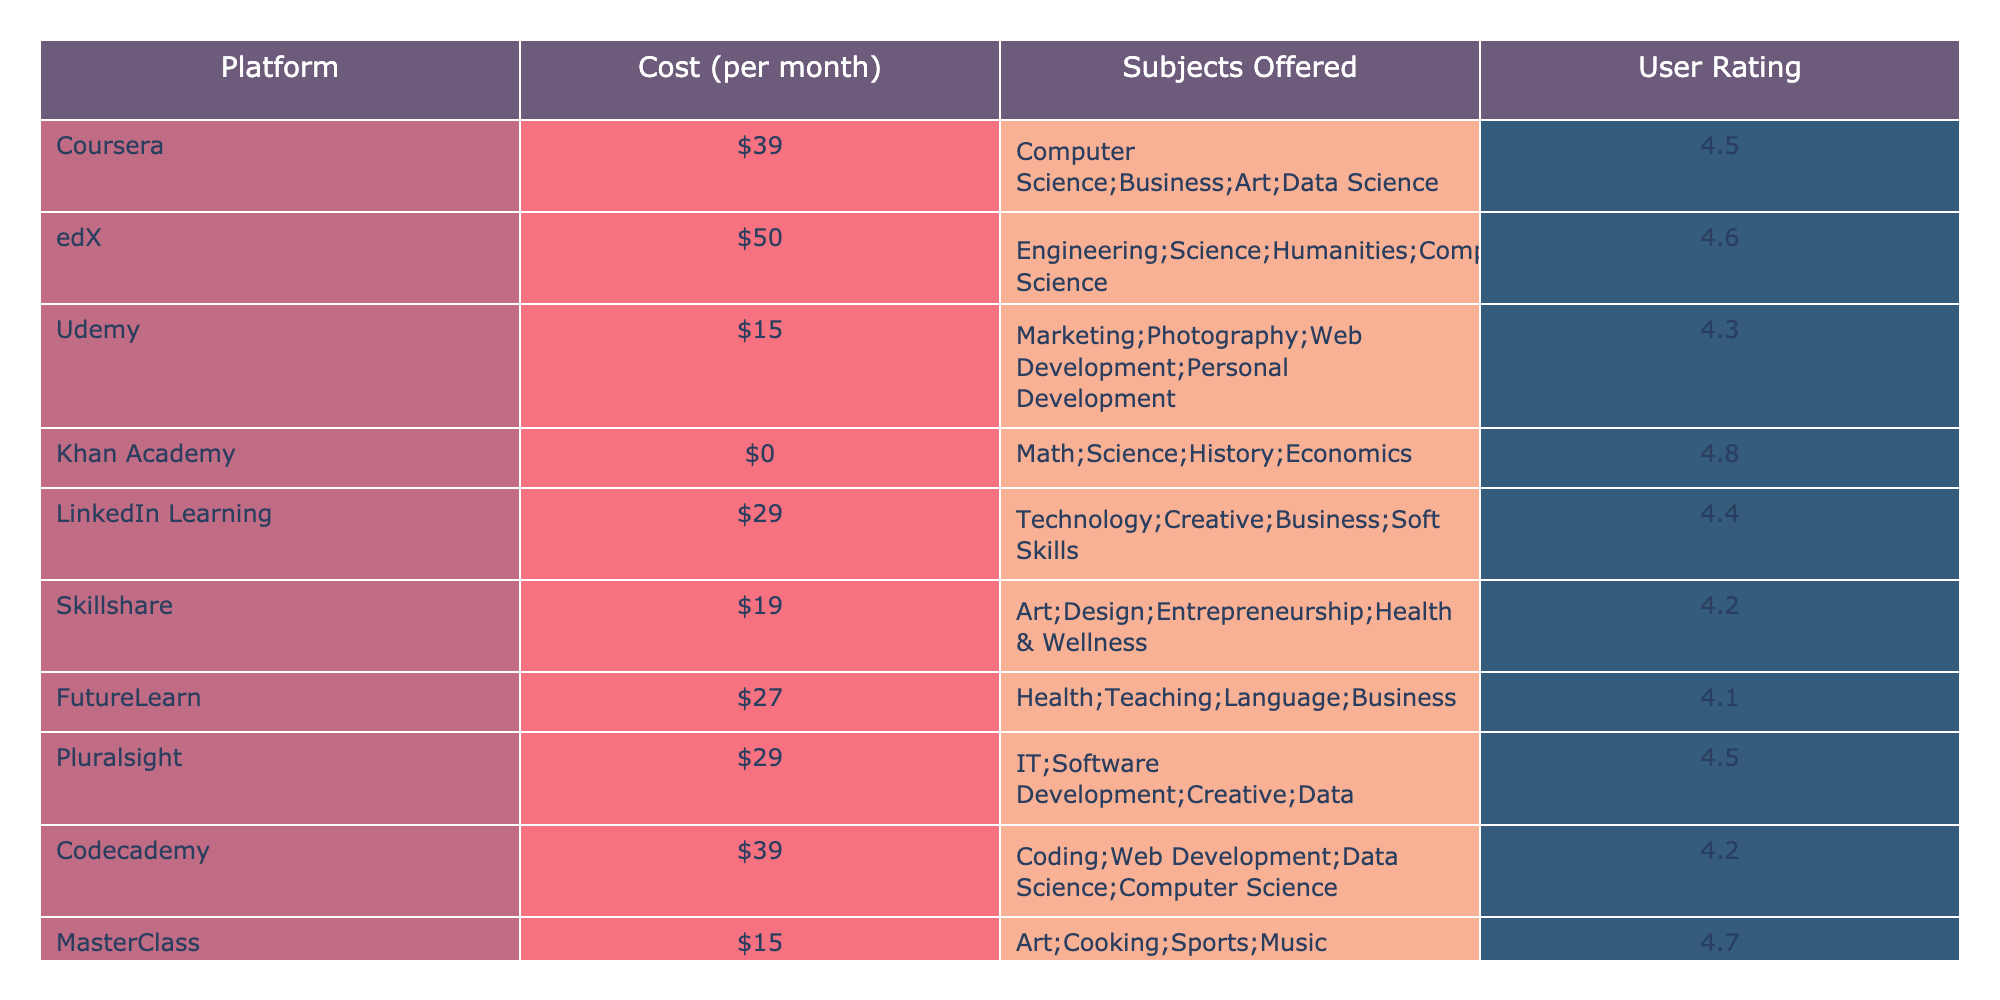What is the cost of Udemy per month? According to the table, Udemy has a cost of $15 per month listed in the Cost column.
Answer: $15 Which platform has the highest user rating? By checking the User Rating column, Khan Academy has the highest rating of 4.8.
Answer: Khan Academy How many subjects does Coursera offer? The Subjects Offered column shows that Coursera offers four subjects: Computer Science, Business, Art, and Data Science.
Answer: 4 Is it true that LinkedIn Learning is cheaper than edX? Looking at the table, LinkedIn Learning costs $29, while edX costs $50. Since $29 is less than $50, the statement is true.
Answer: Yes What is the average user rating for the platforms listed? To find the average, add all user ratings (4.5 + 4.6 + 4.3 + 4.8 + 4.4 + 4.2 + 4.1 + 4.5 + 4.2 + 4.7 = 44.3) and divide by the total number of platforms (10), which equals 44.3 / 10 = 4.43.
Answer: 4.43 Which platform offers the most diverse range of subjects? Coursera offers subjects in Computer Science, Business, Art, and Data Science (4 subjects); edX also offers 4 subjects. The unique identification shows Coursera has more unique subjects while the remaining platforms offer 3 or fewer subjects, hence Coursera and edX share the highest range.
Answer: Coursera and edX If you were to spend $100 on platforms, how many months could you subscribe to Udemy? To find this, divide $100 by the monthly cost of Udemy ($15): 100 / 15 = approximately 6.67. Since you can only buy full months, the maximum number is 6.
Answer: 6 months Which platform is the least expensive while also offering a high user rating? Comparing costs and ratings, Khan Academy costs $0 and has a rating of 4.8, which is the highest user rating. Hence, it’s the least expensive and has the best rating.
Answer: Khan Academy What is the difference in cost between Pluralsight and Skillshare? Pluralsight costs $29 and Skillshare costs $19. The difference is calculated as 29 - 19 = 10.
Answer: $10 If you combine the subjects offered by FutureLearn and Codecademy, how many subjects will you have? FutureLearn offers 4 subjects (Health, Teaching, Language, Business), and Codecademy offers 4 (Coding, Web Development, Data Science, Computer Science), totaling 4 + 4 = 8 distinct subjects combined.
Answer: 8 subjects 